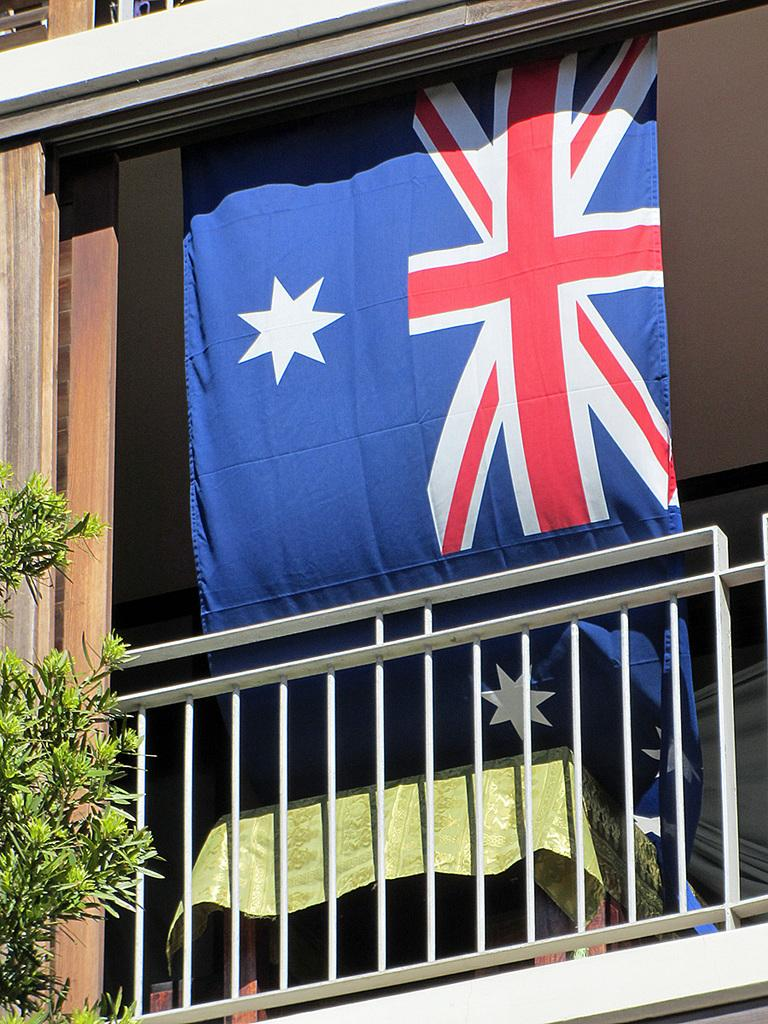What can be seen flying or waving in the image? There is a flag in the image. What type of barrier is present in the image? There is a fence in the image. What type of plant is visible in the image? There is a tree in the image. What other objects can be seen in the image besides the flag, fence, and tree? There are other objects in the image. Where can the brain be seen in the image? There is no brain present in the image. What type of steam is visible in the image? There is no steam present in the image. 